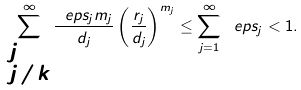<formula> <loc_0><loc_0><loc_500><loc_500>\sum _ { \substack { j = 0 \\ j \neq k } } ^ { \infty } \frac { \ e p s _ { j } m _ { j } } { d _ { j } } \left ( \frac { r _ { j } } { d _ { j } } \right ) ^ { m _ { j } } \leq \sum _ { j = 1 } ^ { \infty } \ e p s _ { j } < 1 .</formula> 